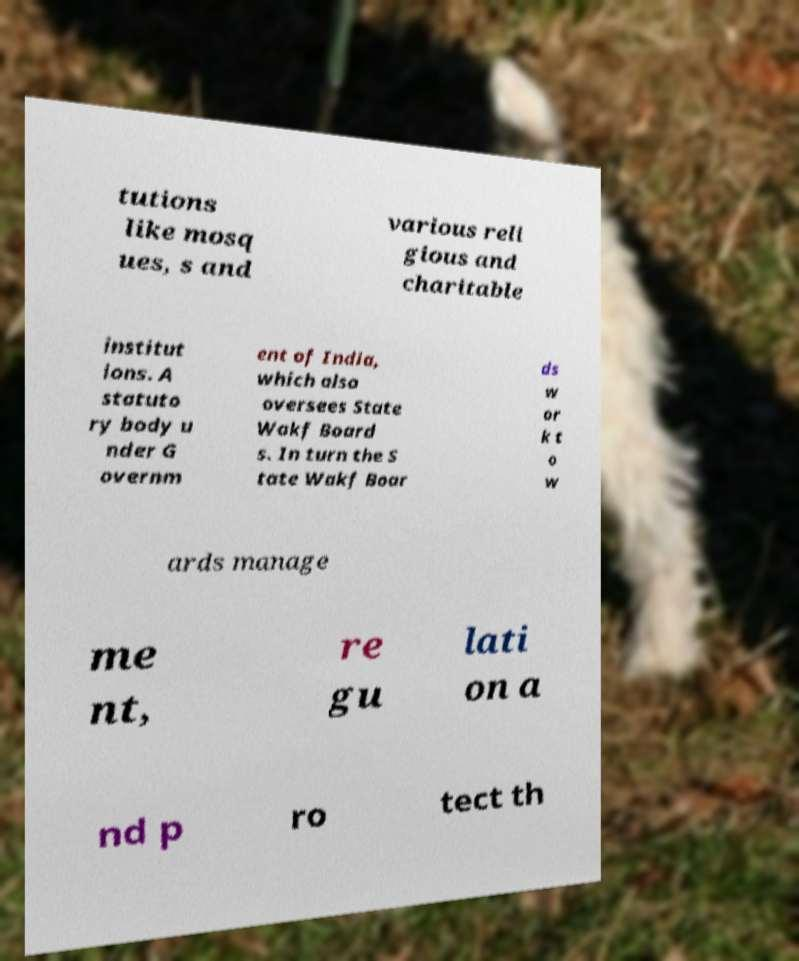Could you extract and type out the text from this image? tutions like mosq ues, s and various reli gious and charitable institut ions. A statuto ry body u nder G overnm ent of India, which also oversees State Wakf Board s. In turn the S tate Wakf Boar ds w or k t o w ards manage me nt, re gu lati on a nd p ro tect th 